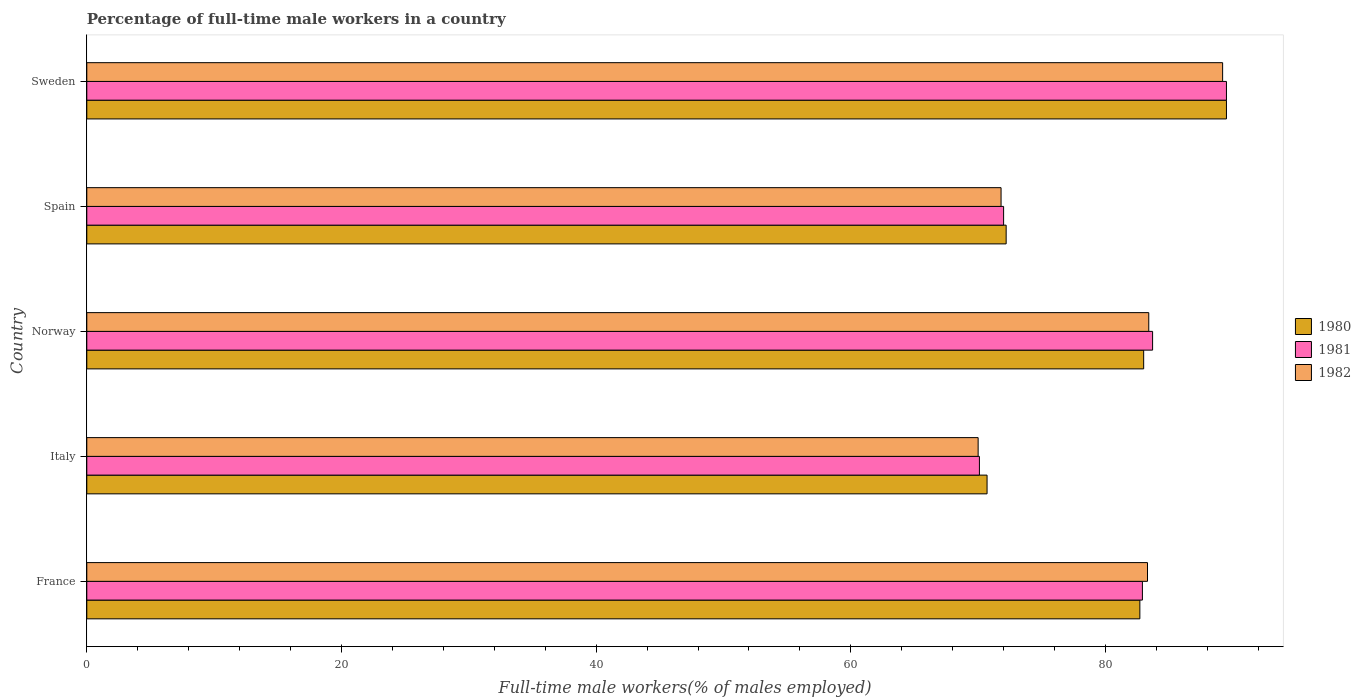How many different coloured bars are there?
Keep it short and to the point. 3. How many groups of bars are there?
Ensure brevity in your answer.  5. Are the number of bars on each tick of the Y-axis equal?
Ensure brevity in your answer.  Yes. How many bars are there on the 2nd tick from the top?
Your response must be concise. 3. How many bars are there on the 1st tick from the bottom?
Your answer should be compact. 3. What is the label of the 3rd group of bars from the top?
Offer a terse response. Norway. In how many cases, is the number of bars for a given country not equal to the number of legend labels?
Make the answer very short. 0. What is the percentage of full-time male workers in 1980 in Spain?
Offer a very short reply. 72.2. Across all countries, what is the maximum percentage of full-time male workers in 1980?
Provide a succinct answer. 89.5. Across all countries, what is the minimum percentage of full-time male workers in 1980?
Your answer should be very brief. 70.7. What is the total percentage of full-time male workers in 1980 in the graph?
Keep it short and to the point. 398.1. What is the difference between the percentage of full-time male workers in 1981 in Italy and that in Norway?
Keep it short and to the point. -13.6. What is the difference between the percentage of full-time male workers in 1981 in Norway and the percentage of full-time male workers in 1980 in France?
Your answer should be very brief. 1. What is the average percentage of full-time male workers in 1980 per country?
Ensure brevity in your answer.  79.62. What is the difference between the percentage of full-time male workers in 1980 and percentage of full-time male workers in 1982 in Spain?
Offer a terse response. 0.4. What is the ratio of the percentage of full-time male workers in 1982 in Italy to that in Sweden?
Your answer should be very brief. 0.78. Is the percentage of full-time male workers in 1982 in Norway less than that in Sweden?
Provide a short and direct response. Yes. Is the difference between the percentage of full-time male workers in 1980 in Norway and Sweden greater than the difference between the percentage of full-time male workers in 1982 in Norway and Sweden?
Provide a short and direct response. No. What is the difference between the highest and the second highest percentage of full-time male workers in 1982?
Give a very brief answer. 5.8. What is the difference between the highest and the lowest percentage of full-time male workers in 1982?
Provide a short and direct response. 19.2. Is the sum of the percentage of full-time male workers in 1982 in Norway and Sweden greater than the maximum percentage of full-time male workers in 1980 across all countries?
Provide a short and direct response. Yes. What does the 3rd bar from the top in Norway represents?
Your response must be concise. 1980. What does the 3rd bar from the bottom in Spain represents?
Your response must be concise. 1982. Is it the case that in every country, the sum of the percentage of full-time male workers in 1981 and percentage of full-time male workers in 1980 is greater than the percentage of full-time male workers in 1982?
Keep it short and to the point. Yes. How many bars are there?
Ensure brevity in your answer.  15. Are all the bars in the graph horizontal?
Provide a succinct answer. Yes. What is the difference between two consecutive major ticks on the X-axis?
Your answer should be compact. 20. Does the graph contain grids?
Ensure brevity in your answer.  No. Where does the legend appear in the graph?
Your answer should be compact. Center right. How are the legend labels stacked?
Make the answer very short. Vertical. What is the title of the graph?
Your answer should be compact. Percentage of full-time male workers in a country. Does "2000" appear as one of the legend labels in the graph?
Your answer should be very brief. No. What is the label or title of the X-axis?
Ensure brevity in your answer.  Full-time male workers(% of males employed). What is the label or title of the Y-axis?
Your answer should be compact. Country. What is the Full-time male workers(% of males employed) of 1980 in France?
Give a very brief answer. 82.7. What is the Full-time male workers(% of males employed) in 1981 in France?
Give a very brief answer. 82.9. What is the Full-time male workers(% of males employed) of 1982 in France?
Your response must be concise. 83.3. What is the Full-time male workers(% of males employed) in 1980 in Italy?
Your response must be concise. 70.7. What is the Full-time male workers(% of males employed) in 1981 in Italy?
Provide a succinct answer. 70.1. What is the Full-time male workers(% of males employed) of 1981 in Norway?
Give a very brief answer. 83.7. What is the Full-time male workers(% of males employed) of 1982 in Norway?
Offer a very short reply. 83.4. What is the Full-time male workers(% of males employed) in 1980 in Spain?
Offer a very short reply. 72.2. What is the Full-time male workers(% of males employed) in 1981 in Spain?
Provide a succinct answer. 72. What is the Full-time male workers(% of males employed) in 1982 in Spain?
Your answer should be compact. 71.8. What is the Full-time male workers(% of males employed) in 1980 in Sweden?
Keep it short and to the point. 89.5. What is the Full-time male workers(% of males employed) in 1981 in Sweden?
Keep it short and to the point. 89.5. What is the Full-time male workers(% of males employed) of 1982 in Sweden?
Provide a short and direct response. 89.2. Across all countries, what is the maximum Full-time male workers(% of males employed) of 1980?
Ensure brevity in your answer.  89.5. Across all countries, what is the maximum Full-time male workers(% of males employed) in 1981?
Offer a terse response. 89.5. Across all countries, what is the maximum Full-time male workers(% of males employed) in 1982?
Keep it short and to the point. 89.2. Across all countries, what is the minimum Full-time male workers(% of males employed) of 1980?
Provide a short and direct response. 70.7. Across all countries, what is the minimum Full-time male workers(% of males employed) of 1981?
Provide a succinct answer. 70.1. What is the total Full-time male workers(% of males employed) of 1980 in the graph?
Provide a succinct answer. 398.1. What is the total Full-time male workers(% of males employed) of 1981 in the graph?
Provide a short and direct response. 398.2. What is the total Full-time male workers(% of males employed) in 1982 in the graph?
Provide a succinct answer. 397.7. What is the difference between the Full-time male workers(% of males employed) of 1980 in France and that in Italy?
Your response must be concise. 12. What is the difference between the Full-time male workers(% of males employed) in 1981 in France and that in Italy?
Offer a terse response. 12.8. What is the difference between the Full-time male workers(% of males employed) of 1980 in France and that in Norway?
Offer a very short reply. -0.3. What is the difference between the Full-time male workers(% of males employed) of 1982 in France and that in Norway?
Offer a very short reply. -0.1. What is the difference between the Full-time male workers(% of males employed) in 1980 in France and that in Spain?
Provide a short and direct response. 10.5. What is the difference between the Full-time male workers(% of males employed) of 1981 in France and that in Spain?
Your answer should be compact. 10.9. What is the difference between the Full-time male workers(% of males employed) in 1980 in France and that in Sweden?
Provide a short and direct response. -6.8. What is the difference between the Full-time male workers(% of males employed) of 1982 in France and that in Sweden?
Give a very brief answer. -5.9. What is the difference between the Full-time male workers(% of males employed) of 1980 in Italy and that in Norway?
Keep it short and to the point. -12.3. What is the difference between the Full-time male workers(% of males employed) of 1981 in Italy and that in Norway?
Keep it short and to the point. -13.6. What is the difference between the Full-time male workers(% of males employed) in 1980 in Italy and that in Spain?
Offer a very short reply. -1.5. What is the difference between the Full-time male workers(% of males employed) in 1982 in Italy and that in Spain?
Give a very brief answer. -1.8. What is the difference between the Full-time male workers(% of males employed) in 1980 in Italy and that in Sweden?
Provide a succinct answer. -18.8. What is the difference between the Full-time male workers(% of males employed) of 1981 in Italy and that in Sweden?
Offer a terse response. -19.4. What is the difference between the Full-time male workers(% of males employed) of 1982 in Italy and that in Sweden?
Offer a terse response. -19.2. What is the difference between the Full-time male workers(% of males employed) of 1980 in Norway and that in Spain?
Give a very brief answer. 10.8. What is the difference between the Full-time male workers(% of males employed) in 1980 in Norway and that in Sweden?
Provide a short and direct response. -6.5. What is the difference between the Full-time male workers(% of males employed) in 1981 in Norway and that in Sweden?
Keep it short and to the point. -5.8. What is the difference between the Full-time male workers(% of males employed) in 1982 in Norway and that in Sweden?
Offer a terse response. -5.8. What is the difference between the Full-time male workers(% of males employed) of 1980 in Spain and that in Sweden?
Your answer should be compact. -17.3. What is the difference between the Full-time male workers(% of males employed) in 1981 in Spain and that in Sweden?
Give a very brief answer. -17.5. What is the difference between the Full-time male workers(% of males employed) of 1982 in Spain and that in Sweden?
Your answer should be very brief. -17.4. What is the difference between the Full-time male workers(% of males employed) of 1980 in France and the Full-time male workers(% of males employed) of 1981 in Italy?
Your answer should be compact. 12.6. What is the difference between the Full-time male workers(% of males employed) in 1981 in France and the Full-time male workers(% of males employed) in 1982 in Italy?
Offer a very short reply. 12.9. What is the difference between the Full-time male workers(% of males employed) of 1980 in France and the Full-time male workers(% of males employed) of 1982 in Norway?
Keep it short and to the point. -0.7. What is the difference between the Full-time male workers(% of males employed) in 1980 in France and the Full-time male workers(% of males employed) in 1982 in Spain?
Provide a short and direct response. 10.9. What is the difference between the Full-time male workers(% of males employed) in 1980 in Italy and the Full-time male workers(% of males employed) in 1981 in Norway?
Make the answer very short. -13. What is the difference between the Full-time male workers(% of males employed) in 1981 in Italy and the Full-time male workers(% of males employed) in 1982 in Norway?
Ensure brevity in your answer.  -13.3. What is the difference between the Full-time male workers(% of males employed) of 1980 in Italy and the Full-time male workers(% of males employed) of 1981 in Spain?
Offer a terse response. -1.3. What is the difference between the Full-time male workers(% of males employed) in 1981 in Italy and the Full-time male workers(% of males employed) in 1982 in Spain?
Offer a terse response. -1.7. What is the difference between the Full-time male workers(% of males employed) in 1980 in Italy and the Full-time male workers(% of males employed) in 1981 in Sweden?
Ensure brevity in your answer.  -18.8. What is the difference between the Full-time male workers(% of males employed) of 1980 in Italy and the Full-time male workers(% of males employed) of 1982 in Sweden?
Your response must be concise. -18.5. What is the difference between the Full-time male workers(% of males employed) of 1981 in Italy and the Full-time male workers(% of males employed) of 1982 in Sweden?
Make the answer very short. -19.1. What is the difference between the Full-time male workers(% of males employed) of 1980 in Norway and the Full-time male workers(% of males employed) of 1982 in Sweden?
Your response must be concise. -6.2. What is the difference between the Full-time male workers(% of males employed) in 1981 in Norway and the Full-time male workers(% of males employed) in 1982 in Sweden?
Provide a short and direct response. -5.5. What is the difference between the Full-time male workers(% of males employed) of 1980 in Spain and the Full-time male workers(% of males employed) of 1981 in Sweden?
Make the answer very short. -17.3. What is the difference between the Full-time male workers(% of males employed) in 1981 in Spain and the Full-time male workers(% of males employed) in 1982 in Sweden?
Keep it short and to the point. -17.2. What is the average Full-time male workers(% of males employed) in 1980 per country?
Give a very brief answer. 79.62. What is the average Full-time male workers(% of males employed) in 1981 per country?
Your answer should be compact. 79.64. What is the average Full-time male workers(% of males employed) of 1982 per country?
Provide a succinct answer. 79.54. What is the difference between the Full-time male workers(% of males employed) of 1980 and Full-time male workers(% of males employed) of 1981 in Italy?
Ensure brevity in your answer.  0.6. What is the difference between the Full-time male workers(% of males employed) of 1981 and Full-time male workers(% of males employed) of 1982 in Italy?
Provide a short and direct response. 0.1. What is the difference between the Full-time male workers(% of males employed) in 1980 and Full-time male workers(% of males employed) in 1981 in Norway?
Give a very brief answer. -0.7. What is the difference between the Full-time male workers(% of males employed) in 1980 and Full-time male workers(% of males employed) in 1982 in Norway?
Offer a terse response. -0.4. What is the difference between the Full-time male workers(% of males employed) of 1981 and Full-time male workers(% of males employed) of 1982 in Spain?
Keep it short and to the point. 0.2. What is the difference between the Full-time male workers(% of males employed) of 1981 and Full-time male workers(% of males employed) of 1982 in Sweden?
Your response must be concise. 0.3. What is the ratio of the Full-time male workers(% of males employed) of 1980 in France to that in Italy?
Make the answer very short. 1.17. What is the ratio of the Full-time male workers(% of males employed) of 1981 in France to that in Italy?
Your answer should be very brief. 1.18. What is the ratio of the Full-time male workers(% of males employed) of 1982 in France to that in Italy?
Your response must be concise. 1.19. What is the ratio of the Full-time male workers(% of males employed) of 1980 in France to that in Norway?
Offer a terse response. 1. What is the ratio of the Full-time male workers(% of males employed) of 1981 in France to that in Norway?
Your answer should be very brief. 0.99. What is the ratio of the Full-time male workers(% of males employed) of 1980 in France to that in Spain?
Provide a short and direct response. 1.15. What is the ratio of the Full-time male workers(% of males employed) in 1981 in France to that in Spain?
Your response must be concise. 1.15. What is the ratio of the Full-time male workers(% of males employed) in 1982 in France to that in Spain?
Make the answer very short. 1.16. What is the ratio of the Full-time male workers(% of males employed) in 1980 in France to that in Sweden?
Provide a succinct answer. 0.92. What is the ratio of the Full-time male workers(% of males employed) of 1981 in France to that in Sweden?
Offer a terse response. 0.93. What is the ratio of the Full-time male workers(% of males employed) in 1982 in France to that in Sweden?
Provide a succinct answer. 0.93. What is the ratio of the Full-time male workers(% of males employed) of 1980 in Italy to that in Norway?
Ensure brevity in your answer.  0.85. What is the ratio of the Full-time male workers(% of males employed) in 1981 in Italy to that in Norway?
Make the answer very short. 0.84. What is the ratio of the Full-time male workers(% of males employed) of 1982 in Italy to that in Norway?
Offer a terse response. 0.84. What is the ratio of the Full-time male workers(% of males employed) of 1980 in Italy to that in Spain?
Keep it short and to the point. 0.98. What is the ratio of the Full-time male workers(% of males employed) in 1981 in Italy to that in Spain?
Your answer should be compact. 0.97. What is the ratio of the Full-time male workers(% of males employed) in 1982 in Italy to that in Spain?
Give a very brief answer. 0.97. What is the ratio of the Full-time male workers(% of males employed) of 1980 in Italy to that in Sweden?
Make the answer very short. 0.79. What is the ratio of the Full-time male workers(% of males employed) of 1981 in Italy to that in Sweden?
Provide a short and direct response. 0.78. What is the ratio of the Full-time male workers(% of males employed) of 1982 in Italy to that in Sweden?
Provide a succinct answer. 0.78. What is the ratio of the Full-time male workers(% of males employed) of 1980 in Norway to that in Spain?
Your response must be concise. 1.15. What is the ratio of the Full-time male workers(% of males employed) in 1981 in Norway to that in Spain?
Offer a terse response. 1.16. What is the ratio of the Full-time male workers(% of males employed) in 1982 in Norway to that in Spain?
Provide a succinct answer. 1.16. What is the ratio of the Full-time male workers(% of males employed) in 1980 in Norway to that in Sweden?
Your answer should be compact. 0.93. What is the ratio of the Full-time male workers(% of males employed) of 1981 in Norway to that in Sweden?
Keep it short and to the point. 0.94. What is the ratio of the Full-time male workers(% of males employed) of 1982 in Norway to that in Sweden?
Provide a succinct answer. 0.94. What is the ratio of the Full-time male workers(% of males employed) in 1980 in Spain to that in Sweden?
Ensure brevity in your answer.  0.81. What is the ratio of the Full-time male workers(% of males employed) in 1981 in Spain to that in Sweden?
Your answer should be very brief. 0.8. What is the ratio of the Full-time male workers(% of males employed) of 1982 in Spain to that in Sweden?
Your answer should be very brief. 0.8. What is the difference between the highest and the second highest Full-time male workers(% of males employed) in 1980?
Provide a short and direct response. 6.5. What is the difference between the highest and the second highest Full-time male workers(% of males employed) in 1981?
Keep it short and to the point. 5.8. What is the difference between the highest and the lowest Full-time male workers(% of males employed) of 1980?
Your answer should be very brief. 18.8. What is the difference between the highest and the lowest Full-time male workers(% of males employed) in 1981?
Provide a succinct answer. 19.4. What is the difference between the highest and the lowest Full-time male workers(% of males employed) of 1982?
Keep it short and to the point. 19.2. 